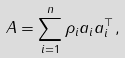Convert formula to latex. <formula><loc_0><loc_0><loc_500><loc_500>A = \sum _ { i = 1 } ^ { n } \rho _ { i } a _ { i } a _ { i } ^ { \top } ,</formula> 